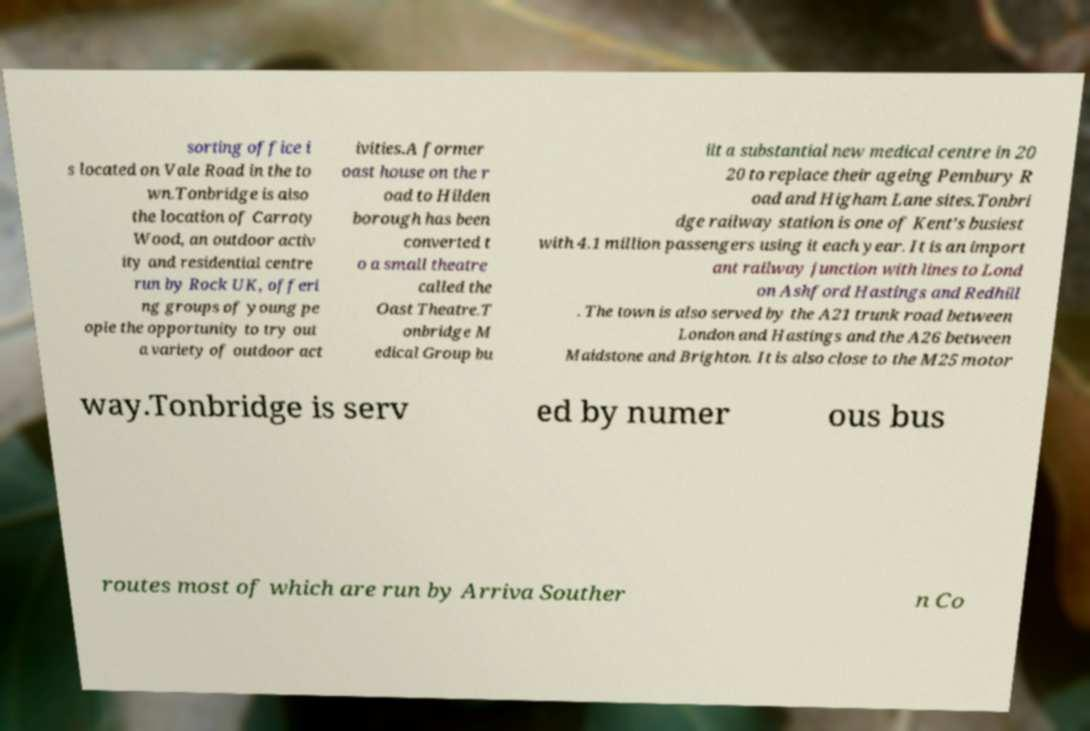What messages or text are displayed in this image? I need them in a readable, typed format. sorting office i s located on Vale Road in the to wn.Tonbridge is also the location of Carroty Wood, an outdoor activ ity and residential centre run by Rock UK, offeri ng groups of young pe ople the opportunity to try out a variety of outdoor act ivities.A former oast house on the r oad to Hilden borough has been converted t o a small theatre called the Oast Theatre.T onbridge M edical Group bu ilt a substantial new medical centre in 20 20 to replace their ageing Pembury R oad and Higham Lane sites.Tonbri dge railway station is one of Kent's busiest with 4.1 million passengers using it each year. It is an import ant railway junction with lines to Lond on Ashford Hastings and Redhill . The town is also served by the A21 trunk road between London and Hastings and the A26 between Maidstone and Brighton. It is also close to the M25 motor way.Tonbridge is serv ed by numer ous bus routes most of which are run by Arriva Souther n Co 